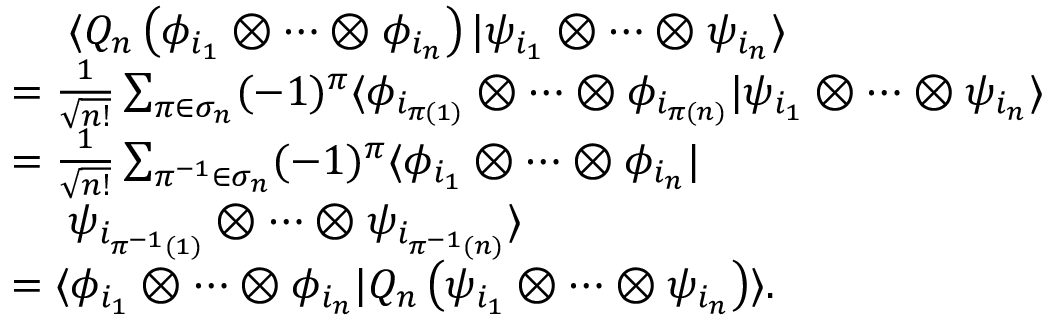<formula> <loc_0><loc_0><loc_500><loc_500>\begin{array} { r l } & { \langle Q _ { n } \left ( \phi _ { i _ { 1 } } \otimes \cdots \otimes \phi _ { i _ { n } } \right ) | \psi _ { i _ { 1 } } \otimes \cdots \otimes \psi _ { i _ { n } } \rangle } \\ & { = \frac { 1 } { \sqrt { n ! } } \sum _ { \pi \in \sigma _ { n } } ( - 1 ) ^ { \pi } \langle \phi _ { i _ { \pi ( 1 ) } } \otimes \cdots \otimes \phi _ { i _ { \pi ( n ) } } | \psi _ { i _ { 1 } } \otimes \cdots \otimes \psi _ { i _ { n } } \rangle } \\ & { = \frac { 1 } { \sqrt { n ! } } \sum _ { \pi ^ { - 1 } \in \sigma _ { n } } ( - 1 ) ^ { \pi } \langle \phi _ { i _ { 1 } } \otimes \cdots \otimes \phi _ { i _ { n } } | } \\ & { \psi _ { i _ { \pi ^ { - 1 } ( 1 ) } } \otimes \cdots \otimes \psi _ { i _ { \pi ^ { - 1 } ( n ) } } \rangle } \\ & { = \langle \phi _ { i _ { 1 } } \otimes \cdots \otimes \phi _ { i _ { n } } | Q _ { n } \left ( \psi _ { i _ { 1 } } \otimes \cdots \otimes \psi _ { i _ { n } } \right ) \rangle . } \end{array}</formula> 